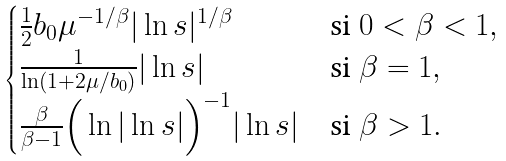Convert formula to latex. <formula><loc_0><loc_0><loc_500><loc_500>\begin{cases} \frac { 1 } { 2 } b _ { 0 } \mu ^ { - 1 / \beta } | \ln s | ^ { 1 / \beta } & \text {si } 0 < \beta < 1 , \\ \frac { 1 } { \ln ( 1 + 2 \mu / b _ { 0 } ) } | \ln s | & \text {si } \beta = 1 , \\ \frac { \beta } { \beta - 1 } \Big { ( } \ln | \ln s | \Big { ) } ^ { - 1 } | \ln s | & \text {si } \beta > 1 . \end{cases}</formula> 